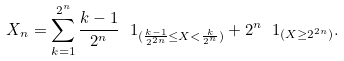Convert formula to latex. <formula><loc_0><loc_0><loc_500><loc_500>X _ { n } = \sum _ { k = 1 } ^ { 2 ^ { n } } \frac { k - 1 } { 2 ^ { n } } \text { } 1 _ { ( \frac { k - 1 } { 2 ^ { 2 n } } \leq X < \frac { k } { 2 ^ { n } } ) } + 2 ^ { n } \text { } 1 _ { ( X \geq 2 ^ { 2 n } ) } .</formula> 